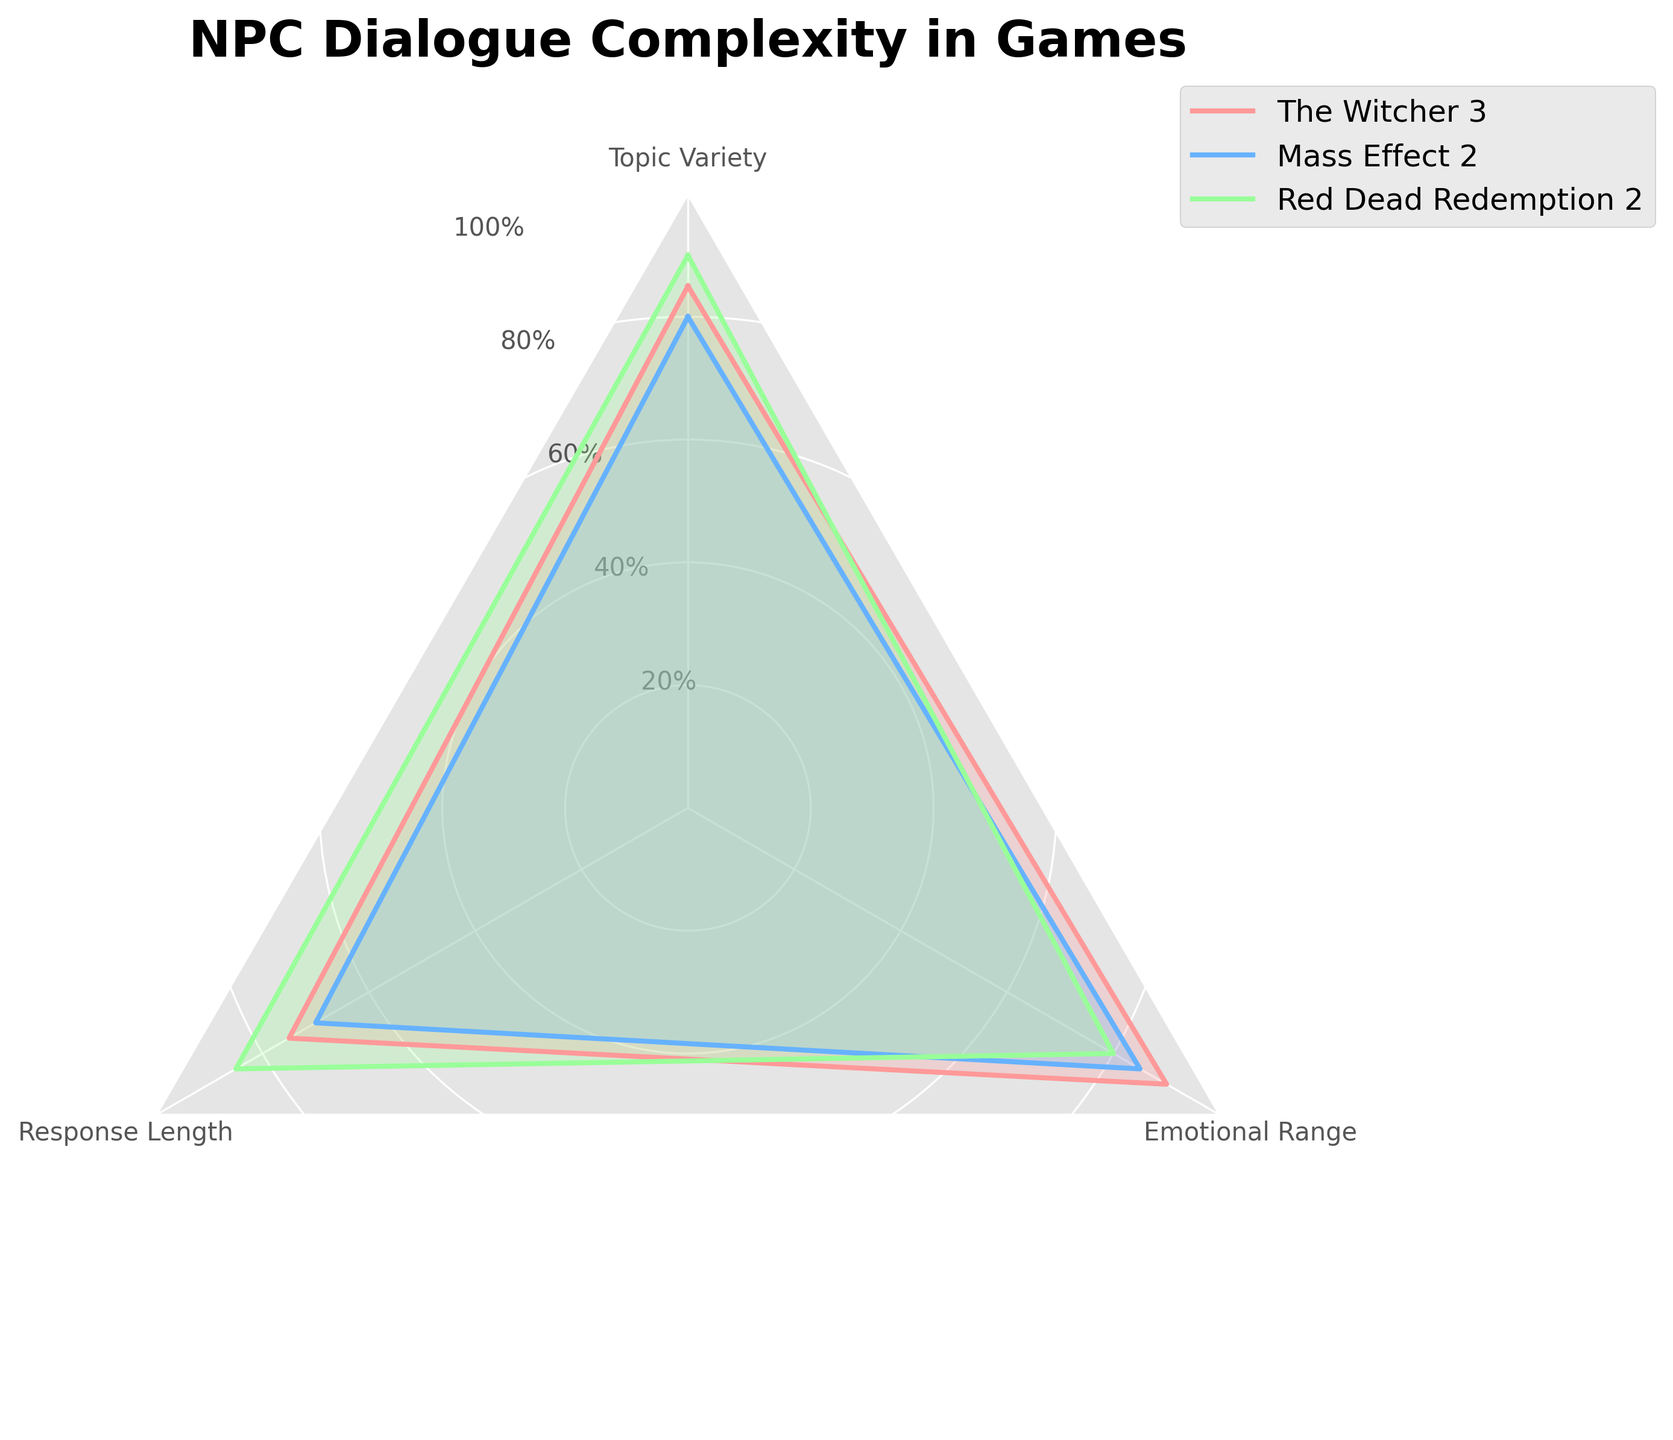What is the maximum value for "Response Length"? To find the maximum value for "Response Length", we look for the highest point on the "Response Length" axis for all games. "Red Dead Redemption 2" has the highest value at 85.
Answer: 85 Which game has the highest overall score in "Topic Variety"? To find the game with the highest "Topic Variety" score, we compare the values: "The Witcher 3" has 85, "Mass Effect 2" has 80, and "Red Dead Redemption 2" has 90. "Red Dead Redemption 2" has the highest score.
Answer: Red Dead Redemption 2 How does the "Emotional Range" of "Mass Effect 2" compare with "The Witcher 3"? We compare the "Emotional Range" values of "Mass Effect 2" and "The Witcher 3". "Mass Effect 2" has a value of 85, while "The Witcher 3" has a value of 90. "The Witcher 3" has a higher "Emotional Range".
Answer: The Witcher 3 has a higher "Emotional Range" What is the average score for "Topic Variety" across all games? To find the average score for "Topic Variety", sum up the scores from all games and divide by the number of games. The scores are 85, 80, and 90. The sum is 255 and dividing by 3 gives an average of 85.
Answer: 85 Which category (Topic Variety, Response Length, Emotional Range) is most uniformly scored across the games? To determine which category is most uniformly scored, we look for the category with the smallest range (difference between highest and lowest values). "Topic Variety" ranges from 80 to 90 (range = 10), "Response Length" ranges from 70 to 85 (range = 15), and "Emotional Range" ranges from 80 to 90 (range = 10). "Topic Variety" and "Emotional Range" are equally uniform.
Answer: Topic Variety and Emotional Range Which game has the smallest difference between its highest and lowest category scores? Calculate the difference between the highest and lowest scores for each game. "The Witcher 3": 90-75=15, "Mass Effect 2": 85-70=15, "Red Dead Redemption 2": 90-80=10. "Red Dead Redemption 2" has the smallest difference of 10.
Answer: Red Dead Redemption 2 Is there any category where all the games score above 70? We check each category to see if all scores are above 70. "Topic Variety" scores: 85, 80, 90. "Response Length" scores: 75, 70, 85. "Emotional Range" scores: 90, 85, 80. All categories have scores above 70.
Answer: Yes 